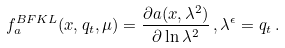<formula> <loc_0><loc_0><loc_500><loc_500>f _ { a } ^ { B F K L } ( x , q _ { t } , \mu ) = \frac { \partial a ( x , \lambda ^ { 2 } ) } { \partial \ln \lambda ^ { 2 } } \, , \lambda ^ { \epsilon } = q _ { t } \, .</formula> 